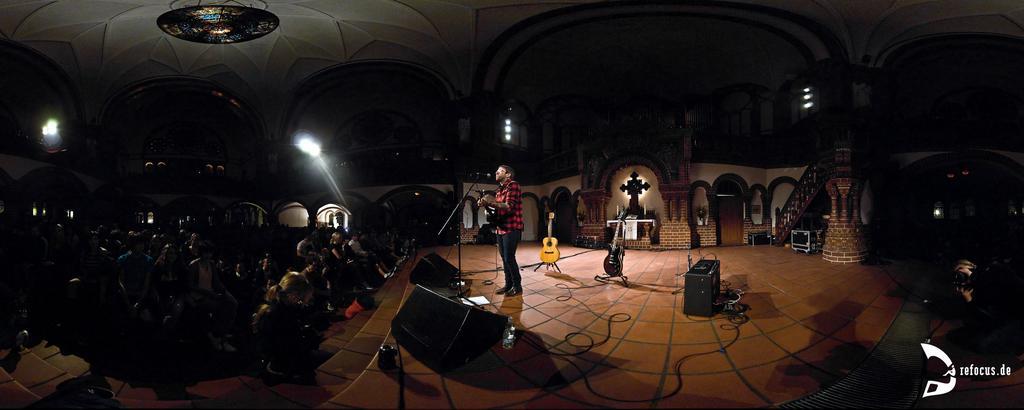Describe this image in one or two sentences. There is a man singing on the mike and he is playing guitar. This is floor and there are musical instruments. Here we can see crowd. In the background we can see lights, door, and a wall. 